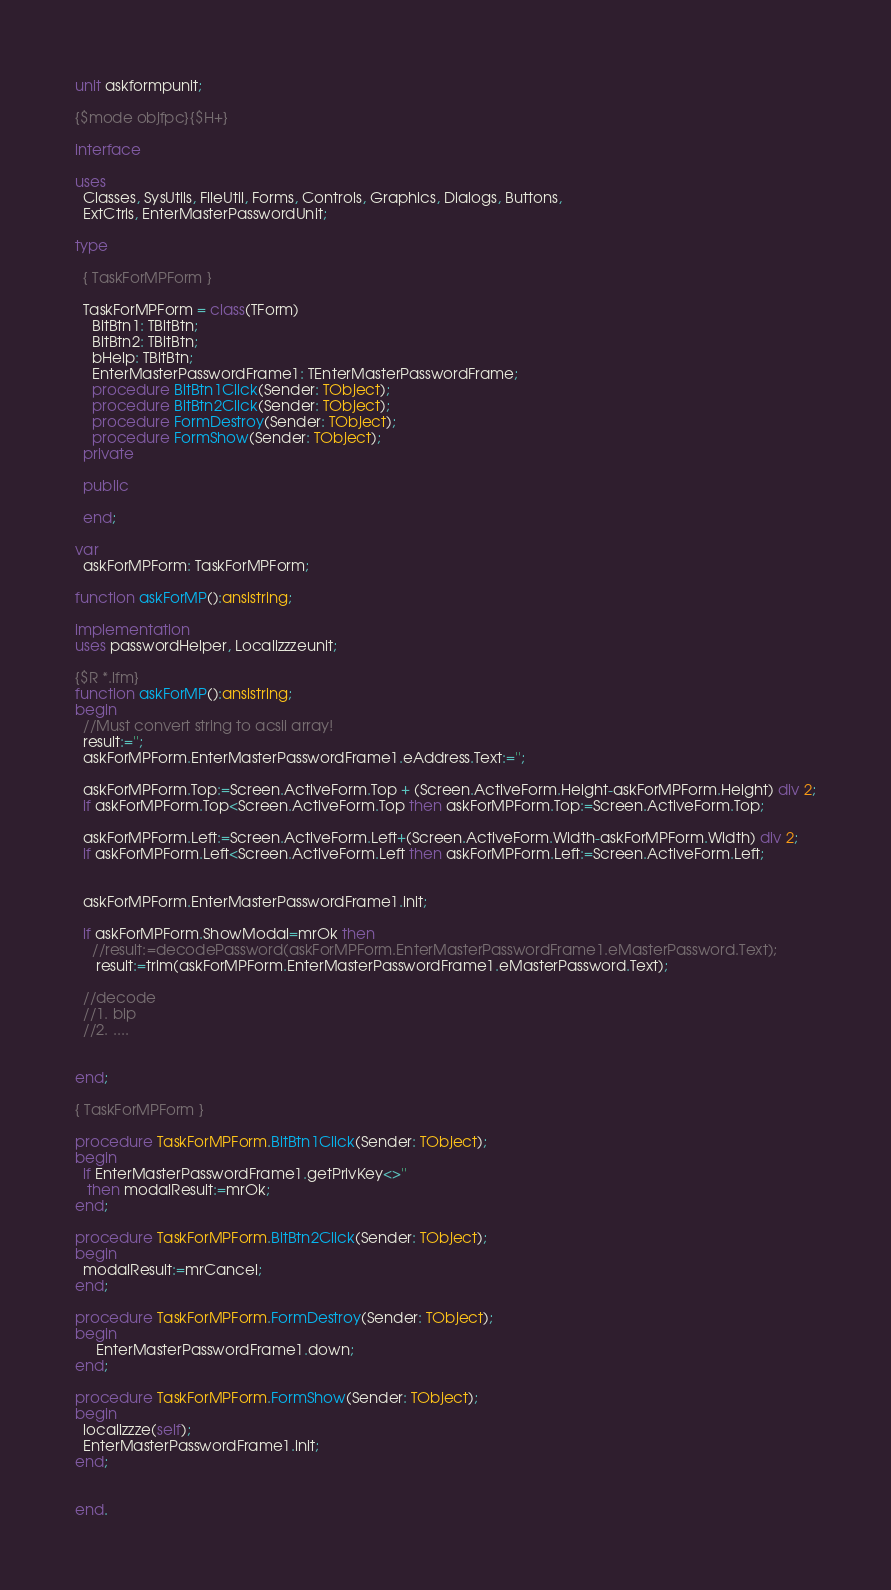Convert code to text. <code><loc_0><loc_0><loc_500><loc_500><_Pascal_>unit askformpunit;

{$mode objfpc}{$H+}

interface

uses
  Classes, SysUtils, FileUtil, Forms, Controls, Graphics, Dialogs, Buttons,
  ExtCtrls, EnterMasterPasswordUnit;

type

  { TaskForMPForm }

  TaskForMPForm = class(TForm)
    BitBtn1: TBitBtn;
    BitBtn2: TBitBtn;
    bHelp: TBitBtn;
    EnterMasterPasswordFrame1: TEnterMasterPasswordFrame;
    procedure BitBtn1Click(Sender: TObject);
    procedure BitBtn2Click(Sender: TObject);
    procedure FormDestroy(Sender: TObject);
    procedure FormShow(Sender: TObject);
  private

  public

  end;

var
  askForMPForm: TaskForMPForm;

function askForMP():ansistring;

implementation
uses passwordHelper, Localizzzeunit;

{$R *.lfm}
function askForMP():ansistring;
begin
  //Must convert string to acsii array!
  result:='';
  askForMPForm.EnterMasterPasswordFrame1.eAddress.Text:='';

  askForMPForm.Top:=Screen.ActiveForm.Top + (Screen.ActiveForm.Height-askForMPForm.Height) div 2;
  if askForMPForm.Top<Screen.ActiveForm.Top then askForMPForm.Top:=Screen.ActiveForm.Top;

  askForMPForm.Left:=Screen.ActiveForm.Left+(Screen.ActiveForm.Width-askForMPForm.Width) div 2;
  if askForMPForm.Left<Screen.ActiveForm.Left then askForMPForm.Left:=Screen.ActiveForm.Left;


  askForMPForm.EnterMasterPasswordFrame1.init;

  if askForMPForm.ShowModal=mrOk then
    //result:=decodePassword(askForMPForm.EnterMasterPasswordFrame1.eMasterPassword.Text);
     result:=trim(askForMPForm.EnterMasterPasswordFrame1.eMasterPassword.Text);

  //decode
  //1. bip
  //2. ....


end;

{ TaskForMPForm }

procedure TaskForMPForm.BitBtn1Click(Sender: TObject);
begin
  if EnterMasterPasswordFrame1.getPrivKey<>''
   then modalResult:=mrOk;
end;

procedure TaskForMPForm.BitBtn2Click(Sender: TObject);
begin
  modalResult:=mrCancel;
end;

procedure TaskForMPForm.FormDestroy(Sender: TObject);
begin
     EnterMasterPasswordFrame1.down;
end;

procedure TaskForMPForm.FormShow(Sender: TObject);
begin
  localizzze(self);
  EnterMasterPasswordFrame1.init;
end;


end.

</code> 